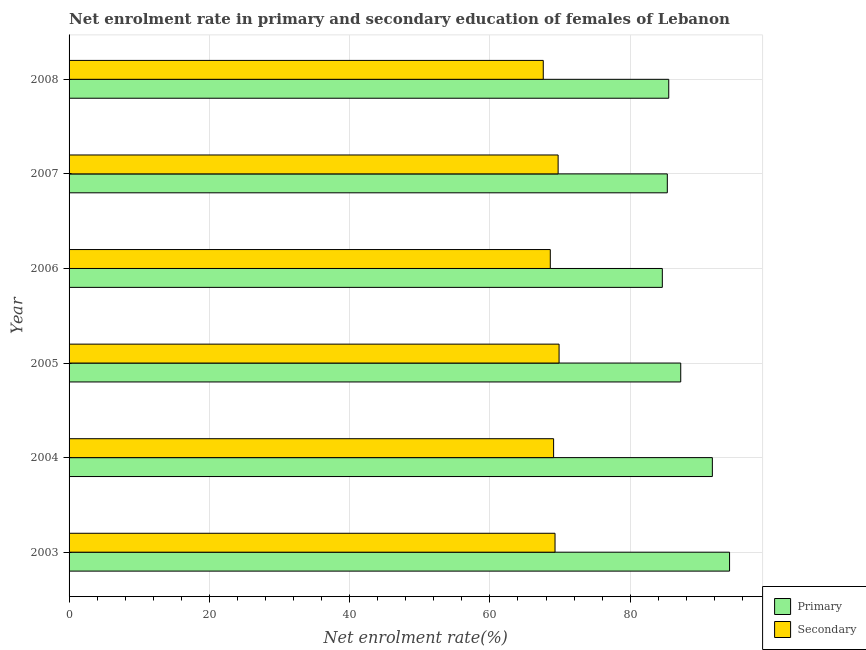How many different coloured bars are there?
Your response must be concise. 2. Are the number of bars per tick equal to the number of legend labels?
Offer a very short reply. Yes. What is the label of the 3rd group of bars from the top?
Provide a succinct answer. 2006. What is the enrollment rate in primary education in 2003?
Provide a succinct answer. 94.16. Across all years, what is the maximum enrollment rate in primary education?
Offer a terse response. 94.16. Across all years, what is the minimum enrollment rate in primary education?
Your answer should be compact. 84.58. In which year was the enrollment rate in primary education maximum?
Your response must be concise. 2003. What is the total enrollment rate in secondary education in the graph?
Your answer should be very brief. 414.15. What is the difference between the enrollment rate in secondary education in 2003 and that in 2004?
Your answer should be very brief. 0.2. What is the difference between the enrollment rate in primary education in 2004 and the enrollment rate in secondary education in 2003?
Provide a succinct answer. 22.43. What is the average enrollment rate in secondary education per year?
Make the answer very short. 69.03. In the year 2007, what is the difference between the enrollment rate in secondary education and enrollment rate in primary education?
Your answer should be compact. -15.57. In how many years, is the enrollment rate in secondary education greater than 28 %?
Keep it short and to the point. 6. Is the enrollment rate in secondary education in 2004 less than that in 2007?
Provide a short and direct response. Yes. Is the difference between the enrollment rate in primary education in 2006 and 2008 greater than the difference between the enrollment rate in secondary education in 2006 and 2008?
Your answer should be very brief. No. What is the difference between the highest and the second highest enrollment rate in primary education?
Offer a very short reply. 2.45. What is the difference between the highest and the lowest enrollment rate in primary education?
Ensure brevity in your answer.  9.58. In how many years, is the enrollment rate in primary education greater than the average enrollment rate in primary education taken over all years?
Keep it short and to the point. 2. Is the sum of the enrollment rate in primary education in 2004 and 2005 greater than the maximum enrollment rate in secondary education across all years?
Provide a succinct answer. Yes. What does the 2nd bar from the top in 2004 represents?
Ensure brevity in your answer.  Primary. What does the 2nd bar from the bottom in 2008 represents?
Your response must be concise. Secondary. How many bars are there?
Make the answer very short. 12. Are all the bars in the graph horizontal?
Offer a very short reply. Yes. How many years are there in the graph?
Make the answer very short. 6. What is the difference between two consecutive major ticks on the X-axis?
Offer a terse response. 20. Does the graph contain grids?
Your response must be concise. Yes. How many legend labels are there?
Offer a very short reply. 2. How are the legend labels stacked?
Make the answer very short. Vertical. What is the title of the graph?
Your response must be concise. Net enrolment rate in primary and secondary education of females of Lebanon. Does "Taxes on exports" appear as one of the legend labels in the graph?
Offer a very short reply. No. What is the label or title of the X-axis?
Provide a succinct answer. Net enrolment rate(%). What is the Net enrolment rate(%) in Primary in 2003?
Ensure brevity in your answer.  94.16. What is the Net enrolment rate(%) of Secondary in 2003?
Give a very brief answer. 69.28. What is the Net enrolment rate(%) of Primary in 2004?
Your answer should be compact. 91.71. What is the Net enrolment rate(%) of Secondary in 2004?
Offer a very short reply. 69.08. What is the Net enrolment rate(%) in Primary in 2005?
Keep it short and to the point. 87.2. What is the Net enrolment rate(%) of Secondary in 2005?
Your response must be concise. 69.86. What is the Net enrolment rate(%) in Primary in 2006?
Ensure brevity in your answer.  84.58. What is the Net enrolment rate(%) of Secondary in 2006?
Ensure brevity in your answer.  68.61. What is the Net enrolment rate(%) in Primary in 2007?
Provide a short and direct response. 85.29. What is the Net enrolment rate(%) of Secondary in 2007?
Give a very brief answer. 69.72. What is the Net enrolment rate(%) of Primary in 2008?
Give a very brief answer. 85.49. What is the Net enrolment rate(%) in Secondary in 2008?
Keep it short and to the point. 67.6. Across all years, what is the maximum Net enrolment rate(%) of Primary?
Make the answer very short. 94.16. Across all years, what is the maximum Net enrolment rate(%) in Secondary?
Give a very brief answer. 69.86. Across all years, what is the minimum Net enrolment rate(%) in Primary?
Your answer should be compact. 84.58. Across all years, what is the minimum Net enrolment rate(%) of Secondary?
Ensure brevity in your answer.  67.6. What is the total Net enrolment rate(%) of Primary in the graph?
Ensure brevity in your answer.  528.44. What is the total Net enrolment rate(%) of Secondary in the graph?
Ensure brevity in your answer.  414.15. What is the difference between the Net enrolment rate(%) in Primary in 2003 and that in 2004?
Give a very brief answer. 2.45. What is the difference between the Net enrolment rate(%) in Secondary in 2003 and that in 2004?
Your answer should be compact. 0.2. What is the difference between the Net enrolment rate(%) in Primary in 2003 and that in 2005?
Give a very brief answer. 6.96. What is the difference between the Net enrolment rate(%) of Secondary in 2003 and that in 2005?
Your answer should be compact. -0.58. What is the difference between the Net enrolment rate(%) of Primary in 2003 and that in 2006?
Offer a terse response. 9.58. What is the difference between the Net enrolment rate(%) of Secondary in 2003 and that in 2006?
Ensure brevity in your answer.  0.67. What is the difference between the Net enrolment rate(%) in Primary in 2003 and that in 2007?
Your answer should be compact. 8.88. What is the difference between the Net enrolment rate(%) of Secondary in 2003 and that in 2007?
Keep it short and to the point. -0.44. What is the difference between the Net enrolment rate(%) of Primary in 2003 and that in 2008?
Give a very brief answer. 8.67. What is the difference between the Net enrolment rate(%) of Secondary in 2003 and that in 2008?
Your answer should be compact. 1.68. What is the difference between the Net enrolment rate(%) in Primary in 2004 and that in 2005?
Offer a terse response. 4.51. What is the difference between the Net enrolment rate(%) of Secondary in 2004 and that in 2005?
Ensure brevity in your answer.  -0.78. What is the difference between the Net enrolment rate(%) in Primary in 2004 and that in 2006?
Keep it short and to the point. 7.13. What is the difference between the Net enrolment rate(%) of Secondary in 2004 and that in 2006?
Provide a short and direct response. 0.47. What is the difference between the Net enrolment rate(%) of Primary in 2004 and that in 2007?
Provide a short and direct response. 6.42. What is the difference between the Net enrolment rate(%) in Secondary in 2004 and that in 2007?
Provide a succinct answer. -0.64. What is the difference between the Net enrolment rate(%) of Primary in 2004 and that in 2008?
Provide a short and direct response. 6.22. What is the difference between the Net enrolment rate(%) in Secondary in 2004 and that in 2008?
Your answer should be compact. 1.47. What is the difference between the Net enrolment rate(%) of Primary in 2005 and that in 2006?
Your answer should be compact. 2.62. What is the difference between the Net enrolment rate(%) in Secondary in 2005 and that in 2006?
Ensure brevity in your answer.  1.25. What is the difference between the Net enrolment rate(%) in Primary in 2005 and that in 2007?
Ensure brevity in your answer.  1.92. What is the difference between the Net enrolment rate(%) of Secondary in 2005 and that in 2007?
Your answer should be compact. 0.14. What is the difference between the Net enrolment rate(%) of Primary in 2005 and that in 2008?
Give a very brief answer. 1.71. What is the difference between the Net enrolment rate(%) of Secondary in 2005 and that in 2008?
Your answer should be compact. 2.25. What is the difference between the Net enrolment rate(%) of Primary in 2006 and that in 2007?
Your answer should be very brief. -0.71. What is the difference between the Net enrolment rate(%) of Secondary in 2006 and that in 2007?
Ensure brevity in your answer.  -1.11. What is the difference between the Net enrolment rate(%) in Primary in 2006 and that in 2008?
Keep it short and to the point. -0.92. What is the difference between the Net enrolment rate(%) of Primary in 2007 and that in 2008?
Your answer should be compact. -0.21. What is the difference between the Net enrolment rate(%) in Secondary in 2007 and that in 2008?
Give a very brief answer. 2.12. What is the difference between the Net enrolment rate(%) of Primary in 2003 and the Net enrolment rate(%) of Secondary in 2004?
Your response must be concise. 25.09. What is the difference between the Net enrolment rate(%) in Primary in 2003 and the Net enrolment rate(%) in Secondary in 2005?
Your response must be concise. 24.31. What is the difference between the Net enrolment rate(%) in Primary in 2003 and the Net enrolment rate(%) in Secondary in 2006?
Ensure brevity in your answer.  25.56. What is the difference between the Net enrolment rate(%) in Primary in 2003 and the Net enrolment rate(%) in Secondary in 2007?
Give a very brief answer. 24.44. What is the difference between the Net enrolment rate(%) in Primary in 2003 and the Net enrolment rate(%) in Secondary in 2008?
Make the answer very short. 26.56. What is the difference between the Net enrolment rate(%) of Primary in 2004 and the Net enrolment rate(%) of Secondary in 2005?
Provide a succinct answer. 21.85. What is the difference between the Net enrolment rate(%) of Primary in 2004 and the Net enrolment rate(%) of Secondary in 2006?
Your answer should be compact. 23.1. What is the difference between the Net enrolment rate(%) of Primary in 2004 and the Net enrolment rate(%) of Secondary in 2007?
Provide a short and direct response. 21.99. What is the difference between the Net enrolment rate(%) in Primary in 2004 and the Net enrolment rate(%) in Secondary in 2008?
Ensure brevity in your answer.  24.11. What is the difference between the Net enrolment rate(%) of Primary in 2005 and the Net enrolment rate(%) of Secondary in 2006?
Provide a short and direct response. 18.6. What is the difference between the Net enrolment rate(%) in Primary in 2005 and the Net enrolment rate(%) in Secondary in 2007?
Provide a short and direct response. 17.48. What is the difference between the Net enrolment rate(%) in Primary in 2005 and the Net enrolment rate(%) in Secondary in 2008?
Your answer should be very brief. 19.6. What is the difference between the Net enrolment rate(%) in Primary in 2006 and the Net enrolment rate(%) in Secondary in 2007?
Ensure brevity in your answer.  14.86. What is the difference between the Net enrolment rate(%) of Primary in 2006 and the Net enrolment rate(%) of Secondary in 2008?
Keep it short and to the point. 16.97. What is the difference between the Net enrolment rate(%) in Primary in 2007 and the Net enrolment rate(%) in Secondary in 2008?
Provide a short and direct response. 17.68. What is the average Net enrolment rate(%) of Primary per year?
Ensure brevity in your answer.  88.07. What is the average Net enrolment rate(%) of Secondary per year?
Your answer should be compact. 69.03. In the year 2003, what is the difference between the Net enrolment rate(%) of Primary and Net enrolment rate(%) of Secondary?
Your answer should be very brief. 24.88. In the year 2004, what is the difference between the Net enrolment rate(%) of Primary and Net enrolment rate(%) of Secondary?
Offer a very short reply. 22.63. In the year 2005, what is the difference between the Net enrolment rate(%) in Primary and Net enrolment rate(%) in Secondary?
Provide a short and direct response. 17.35. In the year 2006, what is the difference between the Net enrolment rate(%) of Primary and Net enrolment rate(%) of Secondary?
Ensure brevity in your answer.  15.97. In the year 2007, what is the difference between the Net enrolment rate(%) of Primary and Net enrolment rate(%) of Secondary?
Offer a very short reply. 15.57. In the year 2008, what is the difference between the Net enrolment rate(%) of Primary and Net enrolment rate(%) of Secondary?
Provide a succinct answer. 17.89. What is the ratio of the Net enrolment rate(%) in Primary in 2003 to that in 2004?
Give a very brief answer. 1.03. What is the ratio of the Net enrolment rate(%) of Primary in 2003 to that in 2005?
Ensure brevity in your answer.  1.08. What is the ratio of the Net enrolment rate(%) of Secondary in 2003 to that in 2005?
Your answer should be compact. 0.99. What is the ratio of the Net enrolment rate(%) in Primary in 2003 to that in 2006?
Your answer should be compact. 1.11. What is the ratio of the Net enrolment rate(%) in Secondary in 2003 to that in 2006?
Provide a short and direct response. 1.01. What is the ratio of the Net enrolment rate(%) in Primary in 2003 to that in 2007?
Your answer should be compact. 1.1. What is the ratio of the Net enrolment rate(%) of Secondary in 2003 to that in 2007?
Provide a short and direct response. 0.99. What is the ratio of the Net enrolment rate(%) of Primary in 2003 to that in 2008?
Offer a very short reply. 1.1. What is the ratio of the Net enrolment rate(%) in Secondary in 2003 to that in 2008?
Your answer should be very brief. 1.02. What is the ratio of the Net enrolment rate(%) of Primary in 2004 to that in 2005?
Your answer should be very brief. 1.05. What is the ratio of the Net enrolment rate(%) in Secondary in 2004 to that in 2005?
Offer a terse response. 0.99. What is the ratio of the Net enrolment rate(%) of Primary in 2004 to that in 2006?
Offer a very short reply. 1.08. What is the ratio of the Net enrolment rate(%) of Primary in 2004 to that in 2007?
Provide a short and direct response. 1.08. What is the ratio of the Net enrolment rate(%) in Secondary in 2004 to that in 2007?
Your response must be concise. 0.99. What is the ratio of the Net enrolment rate(%) of Primary in 2004 to that in 2008?
Make the answer very short. 1.07. What is the ratio of the Net enrolment rate(%) in Secondary in 2004 to that in 2008?
Offer a very short reply. 1.02. What is the ratio of the Net enrolment rate(%) in Primary in 2005 to that in 2006?
Provide a succinct answer. 1.03. What is the ratio of the Net enrolment rate(%) in Secondary in 2005 to that in 2006?
Give a very brief answer. 1.02. What is the ratio of the Net enrolment rate(%) of Primary in 2005 to that in 2007?
Offer a very short reply. 1.02. What is the ratio of the Net enrolment rate(%) of Secondary in 2005 to that in 2008?
Offer a very short reply. 1.03. What is the ratio of the Net enrolment rate(%) in Primary in 2006 to that in 2007?
Give a very brief answer. 0.99. What is the ratio of the Net enrolment rate(%) in Secondary in 2006 to that in 2007?
Give a very brief answer. 0.98. What is the ratio of the Net enrolment rate(%) of Primary in 2006 to that in 2008?
Your answer should be compact. 0.99. What is the ratio of the Net enrolment rate(%) of Secondary in 2006 to that in 2008?
Your answer should be compact. 1.01. What is the ratio of the Net enrolment rate(%) in Primary in 2007 to that in 2008?
Ensure brevity in your answer.  1. What is the ratio of the Net enrolment rate(%) of Secondary in 2007 to that in 2008?
Your answer should be compact. 1.03. What is the difference between the highest and the second highest Net enrolment rate(%) of Primary?
Your answer should be very brief. 2.45. What is the difference between the highest and the second highest Net enrolment rate(%) of Secondary?
Give a very brief answer. 0.14. What is the difference between the highest and the lowest Net enrolment rate(%) in Primary?
Ensure brevity in your answer.  9.58. What is the difference between the highest and the lowest Net enrolment rate(%) of Secondary?
Give a very brief answer. 2.25. 